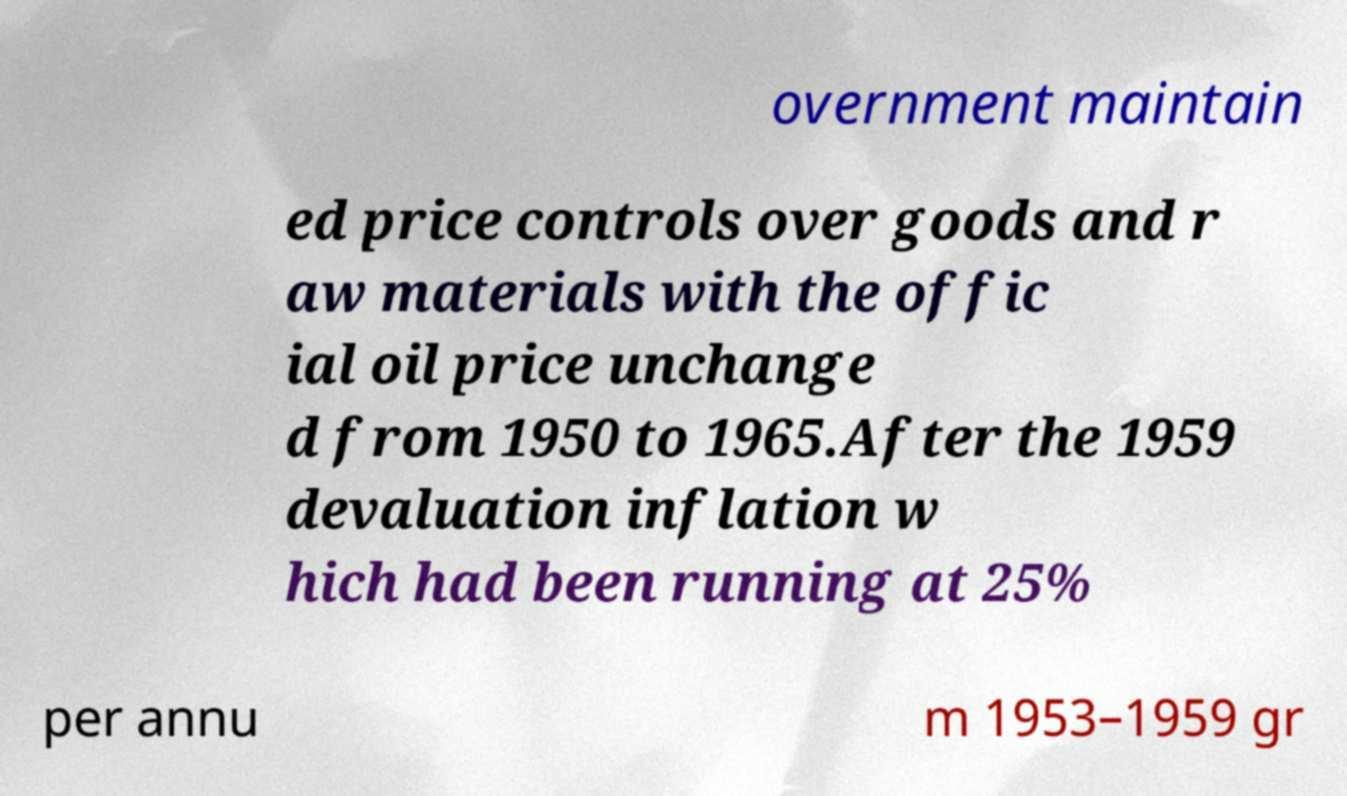There's text embedded in this image that I need extracted. Can you transcribe it verbatim? overnment maintain ed price controls over goods and r aw materials with the offic ial oil price unchange d from 1950 to 1965.After the 1959 devaluation inflation w hich had been running at 25% per annu m 1953–1959 gr 